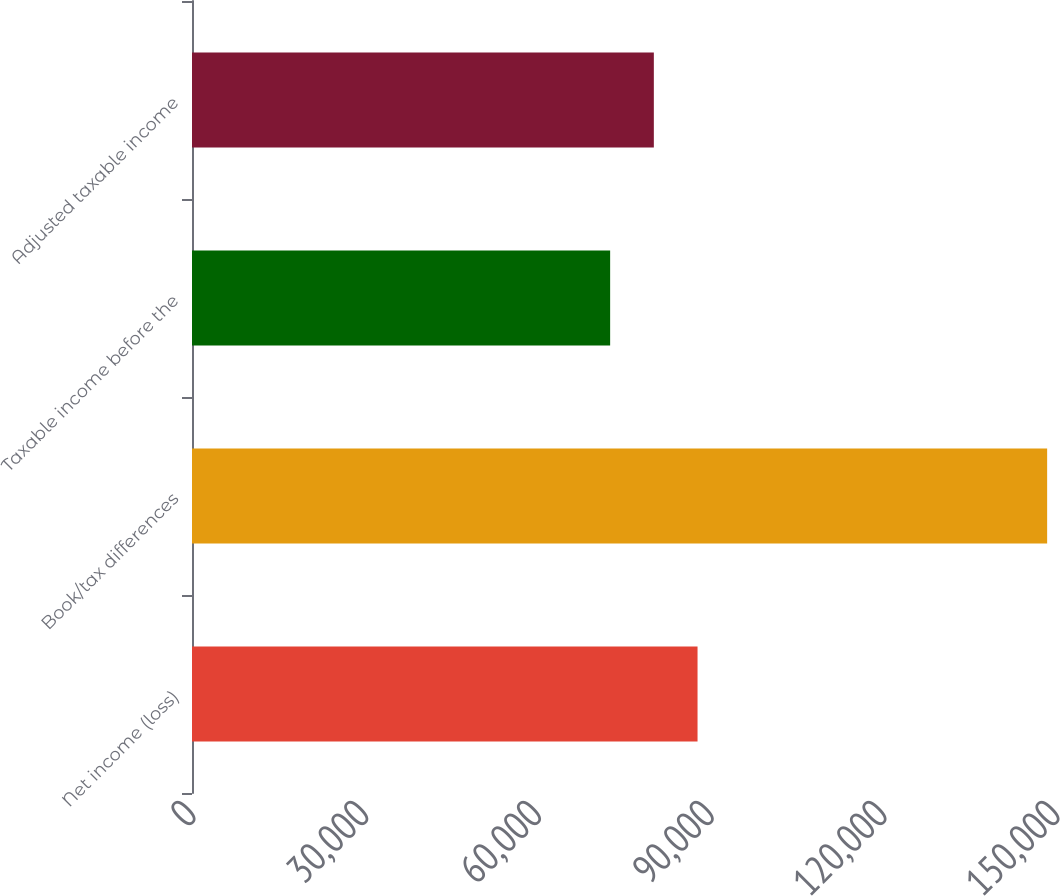<chart> <loc_0><loc_0><loc_500><loc_500><bar_chart><fcel>Net income (loss)<fcel>Book/tax differences<fcel>Taxable income before the<fcel>Adjusted taxable income<nl><fcel>87767.6<fcel>148462<fcel>72594<fcel>80180.8<nl></chart> 